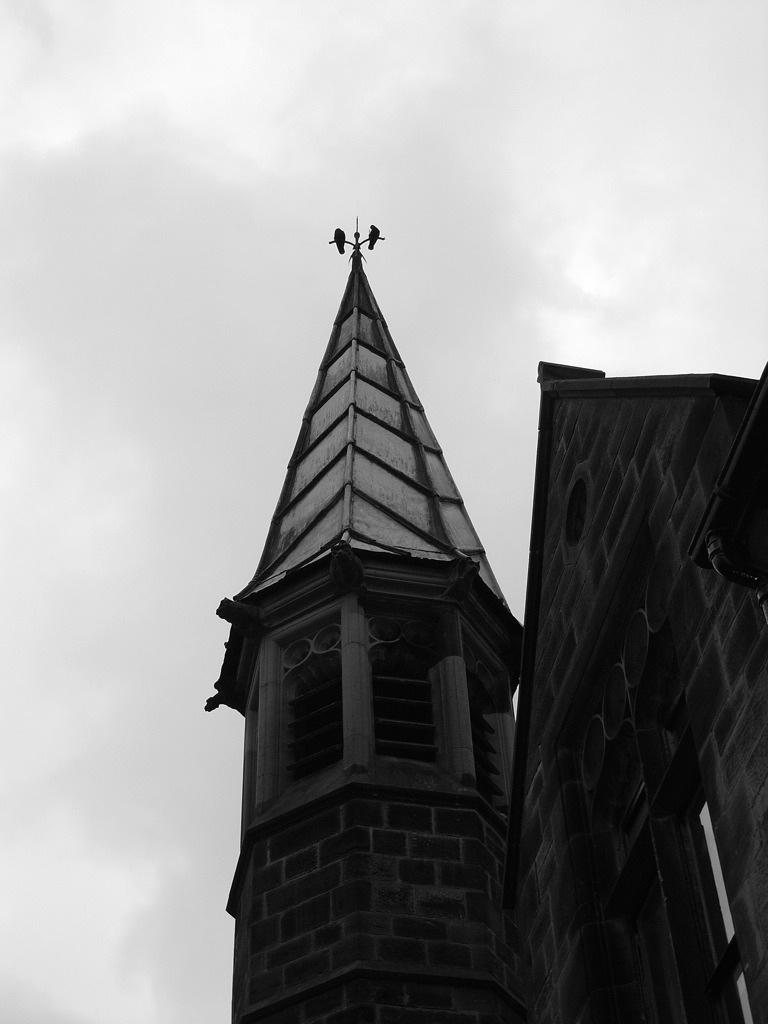What type of structure is present in the image? There is a building in the image. What features can be seen on the building? The building has windows and a door. What can be seen in the background of the image? The sky is visible in the image. Can you make any assumptions about the time of day based on the image? The image may have been taken in the evening, as the sky appears to be darker. How far away is the whistle from the building in the image? There is no whistle present in the image, so it cannot be determined how far away it might be. 